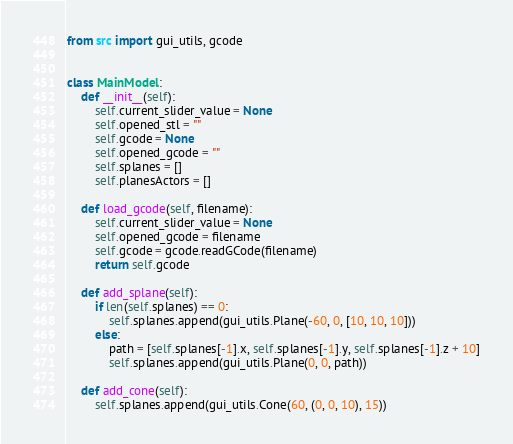Convert code to text. <code><loc_0><loc_0><loc_500><loc_500><_Python_>from src import gui_utils, gcode


class MainModel:
    def __init__(self):
        self.current_slider_value = None
        self.opened_stl = ""
        self.gcode = None
        self.opened_gcode = ""
        self.splanes = []
        self.planesActors = []

    def load_gcode(self, filename):
        self.current_slider_value = None
        self.opened_gcode = filename
        self.gcode = gcode.readGCode(filename)
        return self.gcode

    def add_splane(self):
        if len(self.splanes) == 0:
            self.splanes.append(gui_utils.Plane(-60, 0, [10, 10, 10]))
        else:
            path = [self.splanes[-1].x, self.splanes[-1].y, self.splanes[-1].z + 10]
            self.splanes.append(gui_utils.Plane(0, 0, path))

    def add_cone(self):
        self.splanes.append(gui_utils.Cone(60, (0, 0, 10), 15))
</code> 